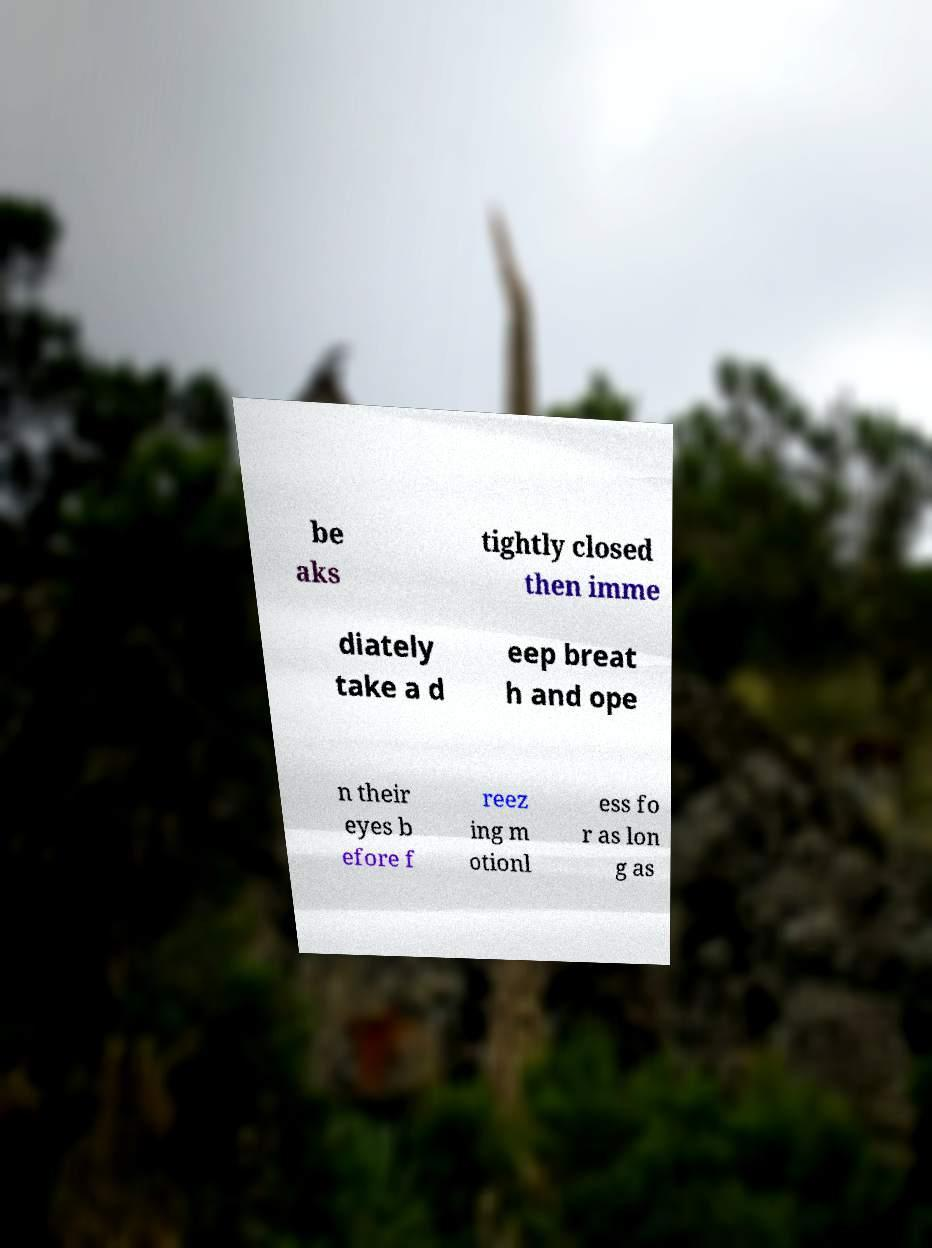Can you accurately transcribe the text from the provided image for me? be aks tightly closed then imme diately take a d eep breat h and ope n their eyes b efore f reez ing m otionl ess fo r as lon g as 